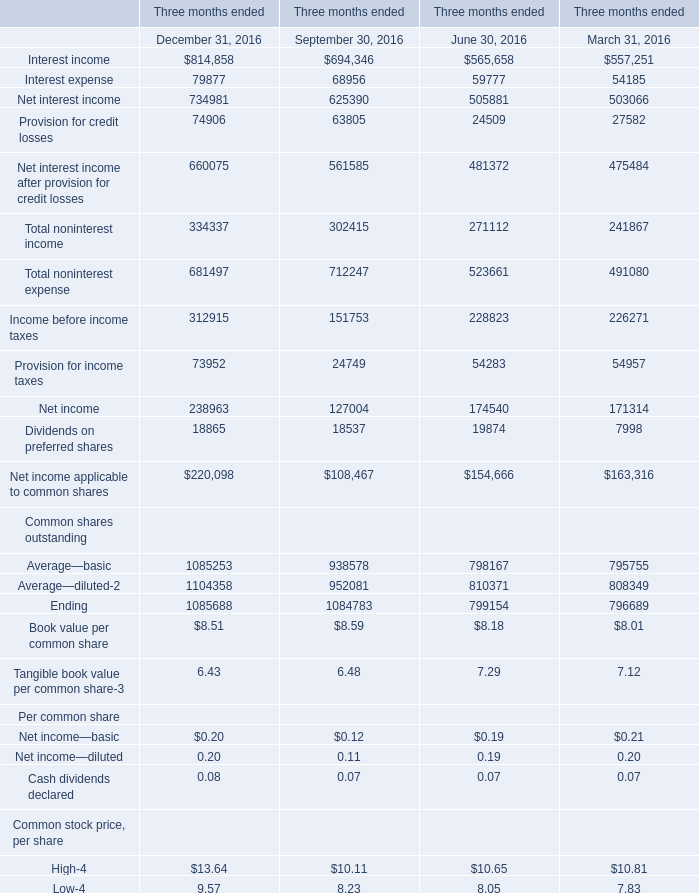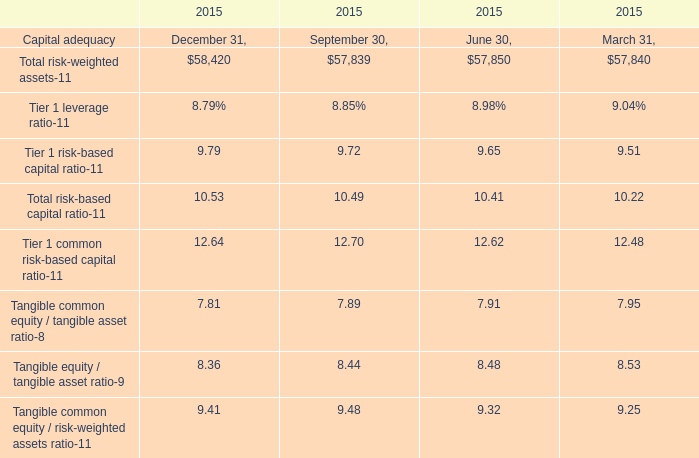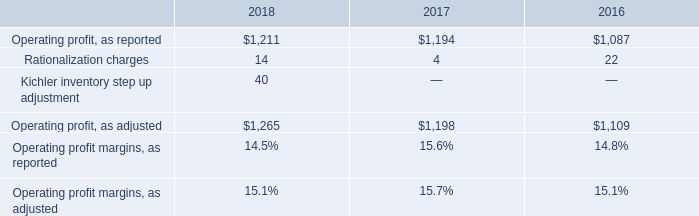what was the percentage growth in the operating profit as reported from 2017 to 2018 
Computations: ((1211 - 1194) / 1194)
Answer: 0.01424. 